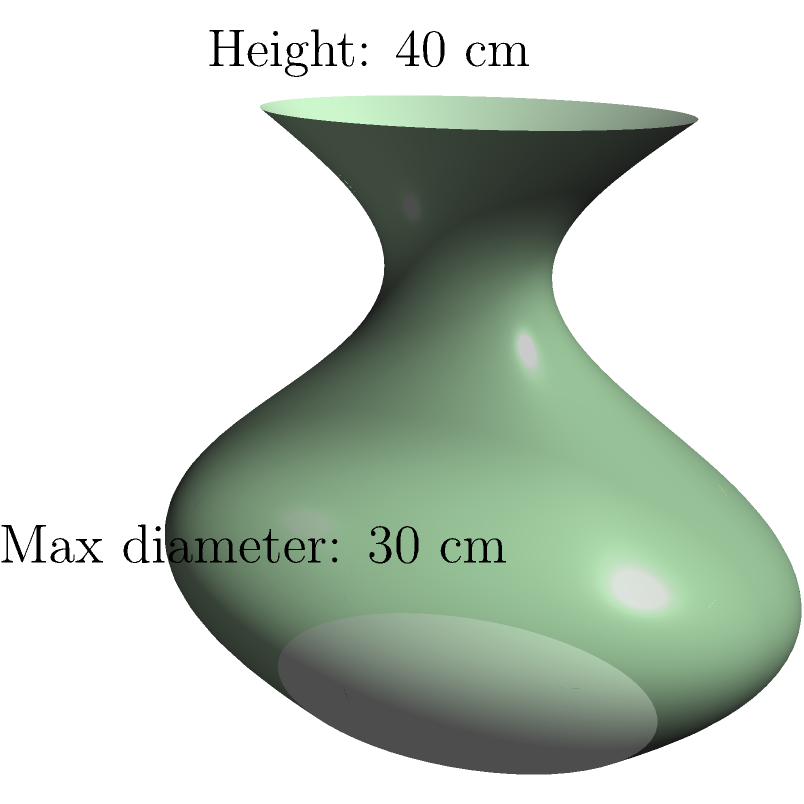You are studying an ancient Greek amphora discovered during an archaeological excavation. Using a 3D scanner, you've created a digital model of the amphora, which can be approximated as a solid of revolution. The amphora has a height of 40 cm and a maximum diameter of 30 cm. The shape of the amphora can be described by the function $r(h) = 15 + 7.5 \sin(\frac{\pi h}{40})$ cm, where $h$ is the height from the base in cm. Calculate the volume of the amphora in liters (L), rounded to the nearest 0.1 L. To calculate the volume of the amphora, we'll use the formula for the volume of a solid of revolution:

$$ V = \pi \int_0^H r^2(h) \, dh $$

Where:
- $V$ is the volume
- $H$ is the total height (40 cm)
- $r(h)$ is the radius as a function of height

Step 1: Substitute the given function for $r(h)$:
$$ V = \pi \int_0^{40} (15 + 7.5 \sin(\frac{\pi h}{40}))^2 \, dh $$

Step 2: Expand the squared term:
$$ V = \pi \int_0^{40} (225 + 225 \sin(\frac{\pi h}{40}) + 56.25 \sin^2(\frac{\pi h}{40})) \, dh $$

Step 3: Integrate each term:
$$ V = \pi [225h - \frac{900}{\pi} \cos(\frac{\pi h}{40}) + \frac{1125}{\pi} h - \frac{1125}{2\pi} \sin(\frac{2\pi h}{40})]_0^{40} $$

Step 4: Evaluate the integral at the limits:
$$ V = \pi (9000 + 900 + 1125 \cdot 40) = \pi \cdot 54900 \approx 172,477.95 \text{ cm}^3 $$

Step 5: Convert to liters (1 L = 1000 cm³) and round to the nearest 0.1 L:
$$ V \approx 17.2 \text{ L} $$
Answer: 17.2 L 